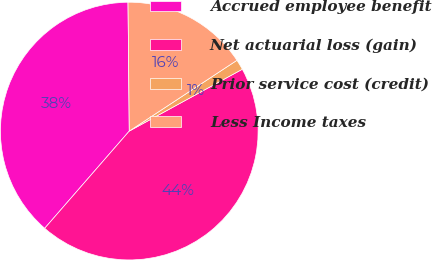<chart> <loc_0><loc_0><loc_500><loc_500><pie_chart><fcel>Accrued employee benefit<fcel>Net actuarial loss (gain)<fcel>Prior service cost (credit)<fcel>Less Income taxes<nl><fcel>38.45%<fcel>44.36%<fcel>1.29%<fcel>15.9%<nl></chart> 